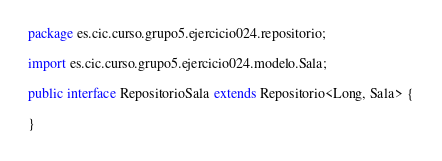<code> <loc_0><loc_0><loc_500><loc_500><_Java_>package es.cic.curso.grupo5.ejercicio024.repositorio;

import es.cic.curso.grupo5.ejercicio024.modelo.Sala;

public interface RepositorioSala extends Repositorio<Long, Sala> {

}
</code> 